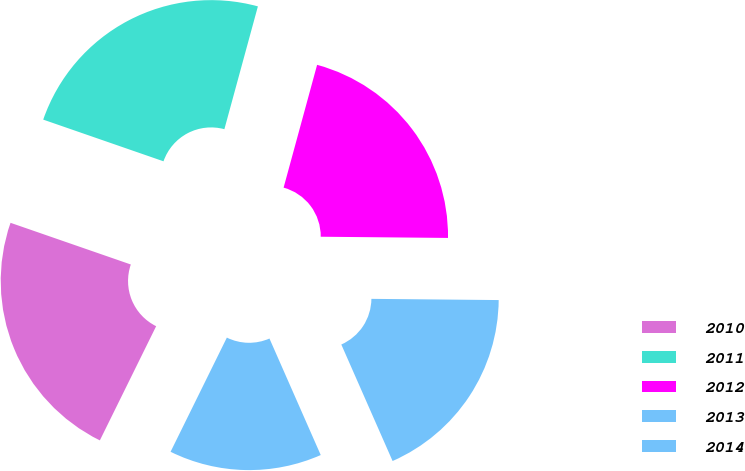Convert chart to OTSL. <chart><loc_0><loc_0><loc_500><loc_500><pie_chart><fcel>2010<fcel>2011<fcel>2012<fcel>2013<fcel>2014<nl><fcel>23.02%<fcel>23.93%<fcel>20.91%<fcel>18.25%<fcel>13.89%<nl></chart> 